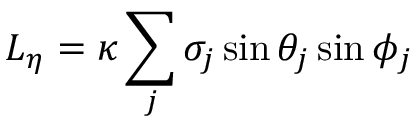<formula> <loc_0><loc_0><loc_500><loc_500>L _ { \eta } = \kappa \sum _ { j } \sigma _ { j } \sin \theta _ { j } \sin \phi _ { j }</formula> 